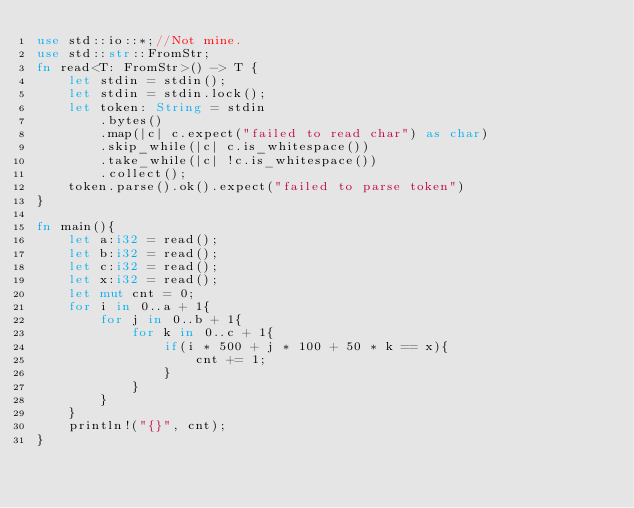Convert code to text. <code><loc_0><loc_0><loc_500><loc_500><_Rust_>use std::io::*;//Not mine.
use std::str::FromStr;
fn read<T: FromStr>() -> T {
    let stdin = stdin();
    let stdin = stdin.lock();
    let token: String = stdin
        .bytes()
        .map(|c| c.expect("failed to read char") as char) 
        .skip_while(|c| c.is_whitespace())
        .take_while(|c| !c.is_whitespace())
        .collect();
    token.parse().ok().expect("failed to parse token")
}

fn main(){
    let a:i32 = read();
    let b:i32 = read();
    let c:i32 = read();
    let x:i32 = read();
    let mut cnt = 0;
    for i in 0..a + 1{
        for j in 0..b + 1{
            for k in 0..c + 1{
                if(i * 500 + j * 100 + 50 * k == x){
                    cnt += 1;
                }
            }
        }
    }
    println!("{}", cnt);
}</code> 